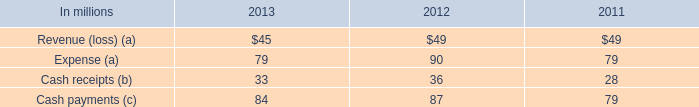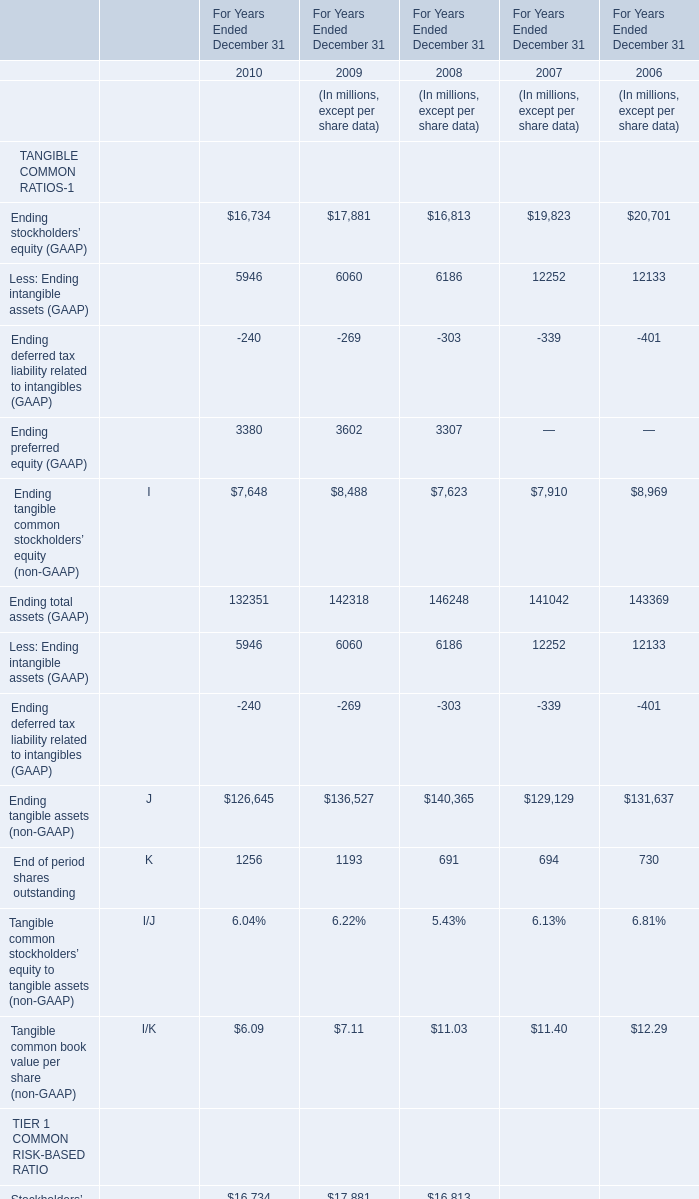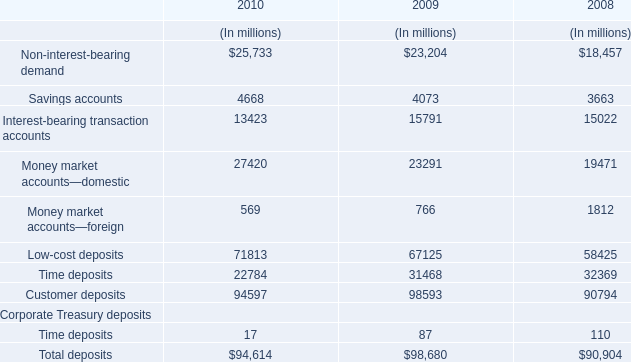What's the average of Ending stockholders’ equity (GAAP) in 2010 and 2009? 
Computations: ((16734 + 17881) / 2)
Answer: 17307.5. 